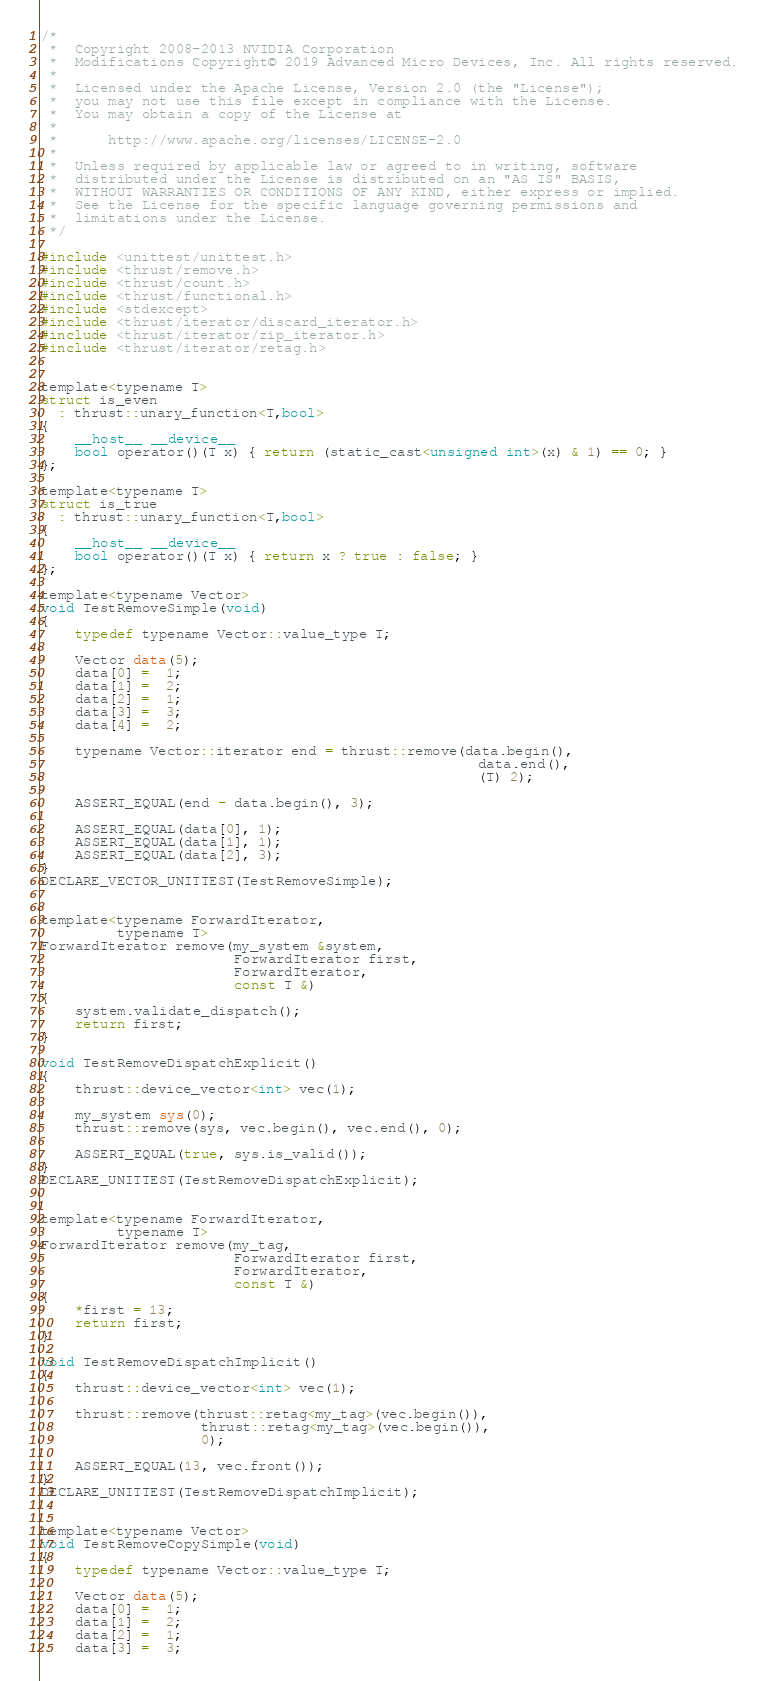<code> <loc_0><loc_0><loc_500><loc_500><_Cuda_>/*
 *  Copyright 2008-2013 NVIDIA Corporation
 *  Modifications Copyright© 2019 Advanced Micro Devices, Inc. All rights reserved.
 *
 *  Licensed under the Apache License, Version 2.0 (the "License");
 *  you may not use this file except in compliance with the License.
 *  You may obtain a copy of the License at
 *
 *      http://www.apache.org/licenses/LICENSE-2.0
 *
 *  Unless required by applicable law or agreed to in writing, software
 *  distributed under the License is distributed on an "AS IS" BASIS,
 *  WITHOUT WARRANTIES OR CONDITIONS OF ANY KIND, either express or implied.
 *  See the License for the specific language governing permissions and
 *  limitations under the License.
 */

#include <unittest/unittest.h>
#include <thrust/remove.h>
#include <thrust/count.h>
#include <thrust/functional.h>
#include <stdexcept>
#include <thrust/iterator/discard_iterator.h>
#include <thrust/iterator/zip_iterator.h>
#include <thrust/iterator/retag.h>


template<typename T>
struct is_even
  : thrust::unary_function<T,bool>
{
    __host__ __device__
    bool operator()(T x) { return (static_cast<unsigned int>(x) & 1) == 0; }
};

template<typename T>
struct is_true
  : thrust::unary_function<T,bool>
{
    __host__ __device__
    bool operator()(T x) { return x ? true : false; }
};

template<typename Vector>
void TestRemoveSimple(void)
{
    typedef typename Vector::value_type T;

    Vector data(5);
    data[0] =  1;
    data[1] =  2;
    data[2] =  1;
    data[3] =  3;
    data[4] =  2;

    typename Vector::iterator end = thrust::remove(data.begin(),
                                                    data.end(),
                                                    (T) 2);

    ASSERT_EQUAL(end - data.begin(), 3);

    ASSERT_EQUAL(data[0], 1);
    ASSERT_EQUAL(data[1], 1);
    ASSERT_EQUAL(data[2], 3);
}
DECLARE_VECTOR_UNITTEST(TestRemoveSimple);


template<typename ForwardIterator,
         typename T>
ForwardIterator remove(my_system &system,
                       ForwardIterator first,
                       ForwardIterator,
                       const T &)
{
    system.validate_dispatch();
    return first;
}

void TestRemoveDispatchExplicit()
{
    thrust::device_vector<int> vec(1);

    my_system sys(0);
    thrust::remove(sys, vec.begin(), vec.end(), 0);

    ASSERT_EQUAL(true, sys.is_valid());
}
DECLARE_UNITTEST(TestRemoveDispatchExplicit);


template<typename ForwardIterator,
         typename T>
ForwardIterator remove(my_tag,
                       ForwardIterator first,
                       ForwardIterator,
                       const T &)
{
    *first = 13;
    return first;
}

void TestRemoveDispatchImplicit()
{
    thrust::device_vector<int> vec(1);

    thrust::remove(thrust::retag<my_tag>(vec.begin()),
                   thrust::retag<my_tag>(vec.begin()),
                   0);

    ASSERT_EQUAL(13, vec.front());
}
DECLARE_UNITTEST(TestRemoveDispatchImplicit);


template<typename Vector>
void TestRemoveCopySimple(void)
{
    typedef typename Vector::value_type T;

    Vector data(5);
    data[0] =  1;
    data[1] =  2;
    data[2] =  1;
    data[3] =  3;</code> 